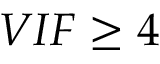Convert formula to latex. <formula><loc_0><loc_0><loc_500><loc_500>V I F \geq 4</formula> 